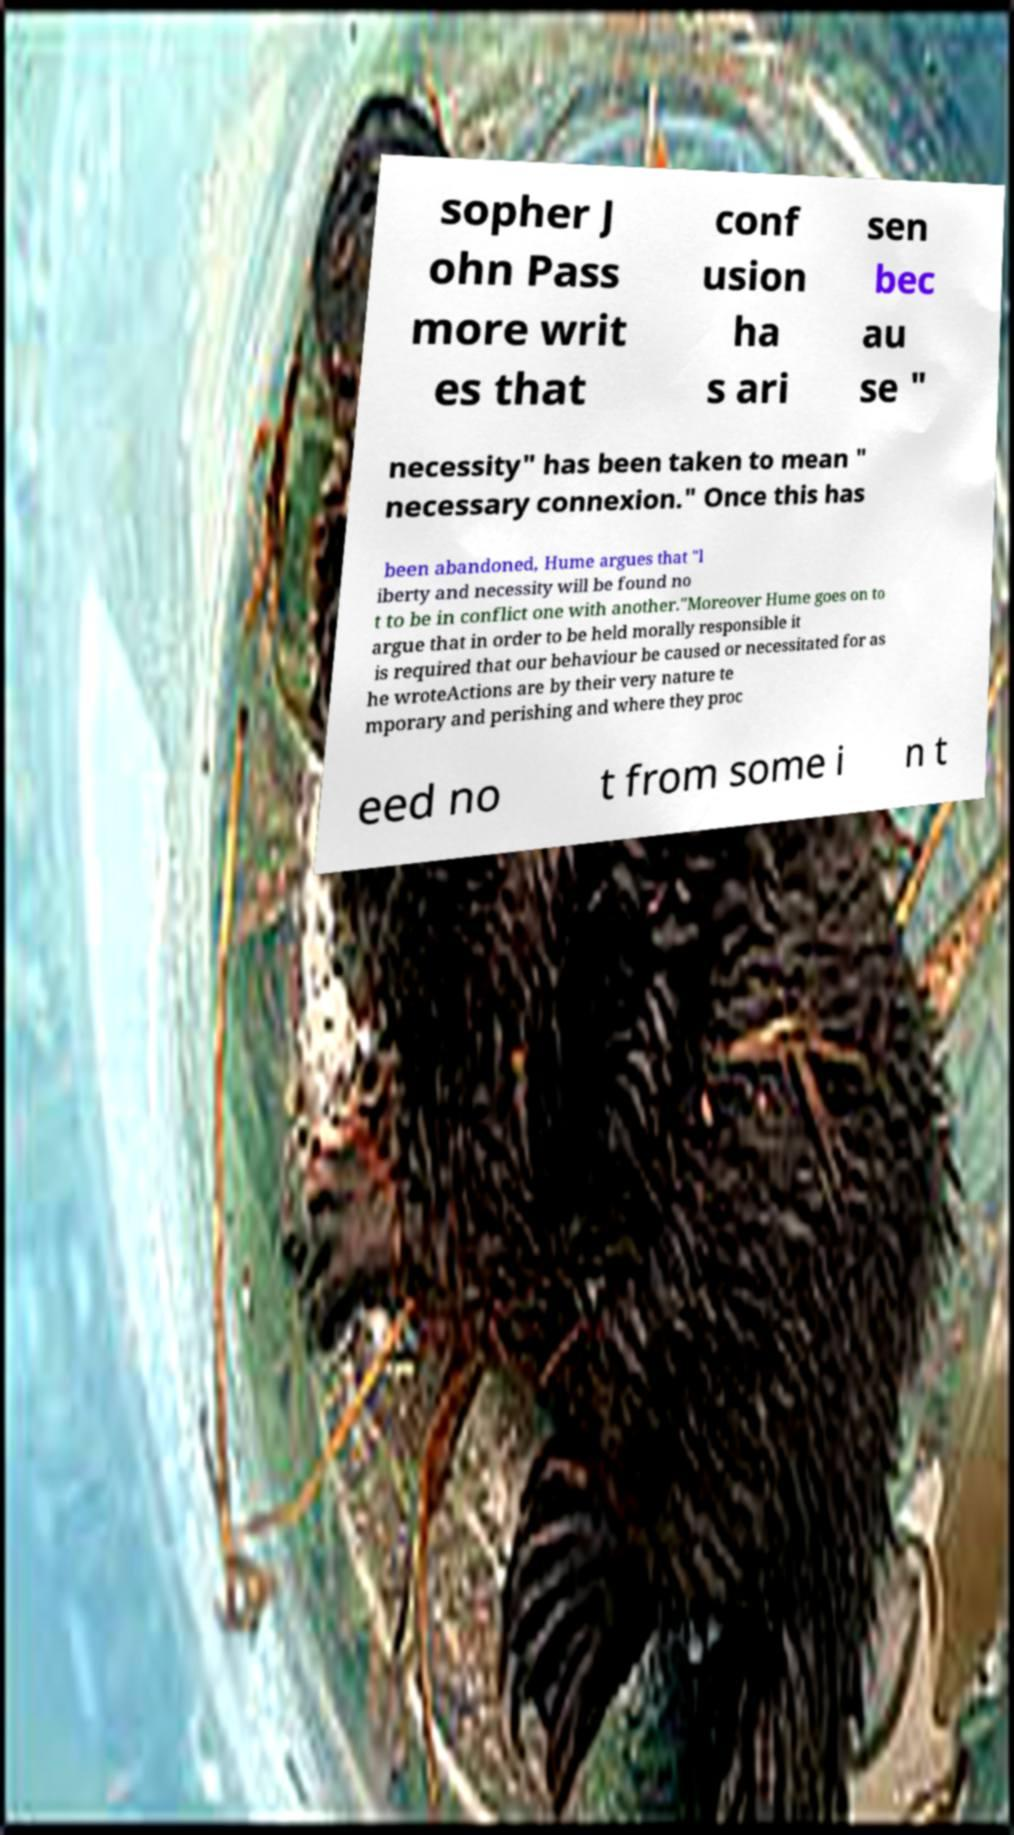Could you assist in decoding the text presented in this image and type it out clearly? sopher J ohn Pass more writ es that conf usion ha s ari sen bec au se " necessity" has been taken to mean " necessary connexion." Once this has been abandoned, Hume argues that "l iberty and necessity will be found no t to be in conflict one with another."Moreover Hume goes on to argue that in order to be held morally responsible it is required that our behaviour be caused or necessitated for as he wroteActions are by their very nature te mporary and perishing and where they proc eed no t from some i n t 